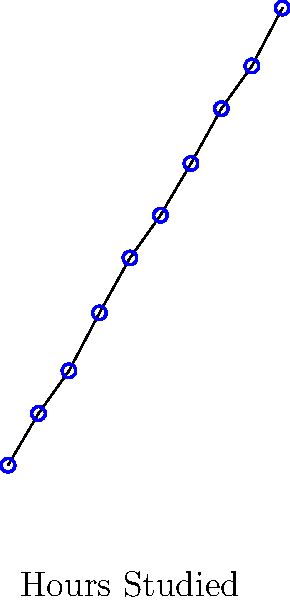Based on the scatter plot, which of the following statements best describes the relationship between hours studied and test scores?

A) There is a strong negative correlation
B) There is a weak positive correlation
C) There is a strong positive correlation
D) There is no apparent correlation To interpret the scatter plot and determine the relationship between hours studied and test scores, we need to follow these steps:

1. Observe the overall pattern of the data points:
   The points seem to form a clear upward trend from left to right.

2. Assess the strength of the relationship:
   The points are closely clustered around an imaginary line, with little scatter.

3. Determine the direction of the relationship:
   As the x-axis values (hours studied) increase, the y-axis values (test scores) also increase.

4. Evaluate the consistency of the pattern:
   The relationship appears consistent throughout the range of data.

5. Consider the slope of the imaginary line:
   The line would have a steep positive slope, indicating a strong relationship.

6. Rule out other options:
   A) Negative correlation would show a downward trend, which is not the case.
   B) Weak correlation would show more scattered points with less clear trend.
   D) No correlation would show random scatter with no clear pattern.

Based on these observations, we can conclude that there is a strong positive correlation between hours studied and test scores. This means that as students spend more time studying, their test scores tend to increase significantly and consistently.
Answer: C) There is a strong positive correlation 